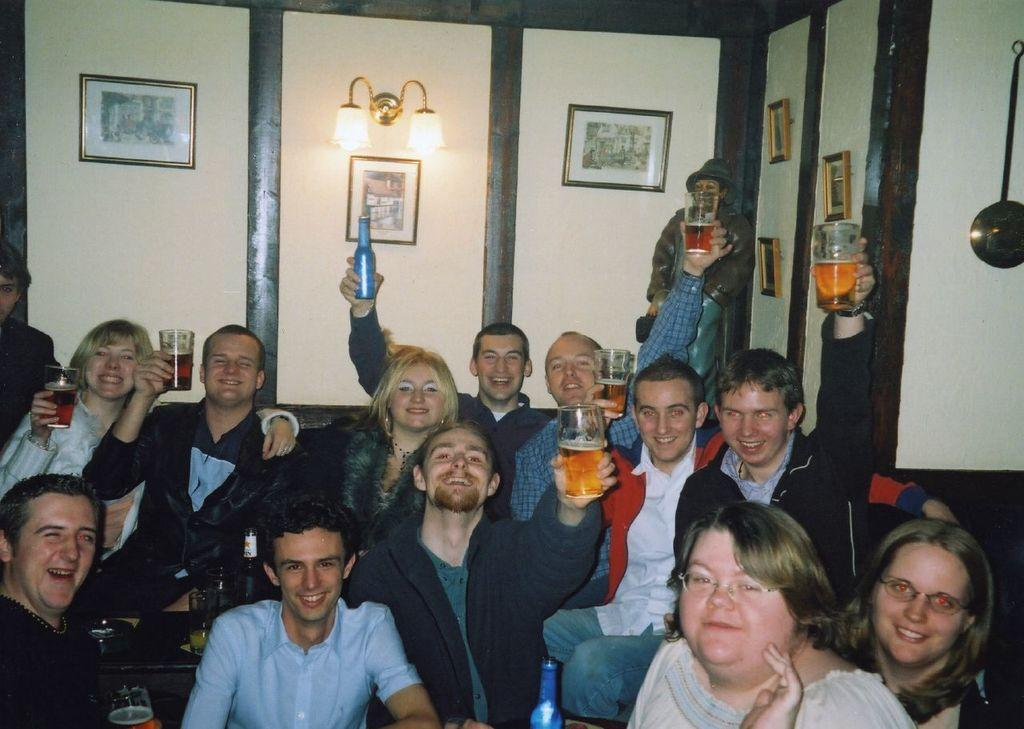What can be seen on the wall in the image? There are different types of pictures on the wall. Can you describe the lighting in the image? There is a light on the wall. What is the mood of the persons in the image? The persons in the image are smiling. What are the persons holding in the image? The persons are holding glasses. What objects are on the table in the image? There is a bottle and glasses on the table. How far away is the person standing from the others in the image? A person is standing far from the others. What type of scene is the cook preparing in the image? There is no cook or scene being prepared in the image. Can you describe the behavior of the squirrel in the image? There is no squirrel present in the image. 